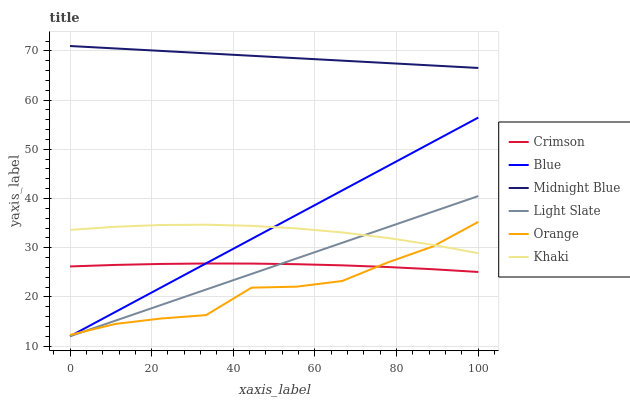Does Orange have the minimum area under the curve?
Answer yes or no. Yes. Does Midnight Blue have the maximum area under the curve?
Answer yes or no. Yes. Does Khaki have the minimum area under the curve?
Answer yes or no. No. Does Khaki have the maximum area under the curve?
Answer yes or no. No. Is Light Slate the smoothest?
Answer yes or no. Yes. Is Orange the roughest?
Answer yes or no. Yes. Is Khaki the smoothest?
Answer yes or no. No. Is Khaki the roughest?
Answer yes or no. No. Does Blue have the lowest value?
Answer yes or no. Yes. Does Khaki have the lowest value?
Answer yes or no. No. Does Midnight Blue have the highest value?
Answer yes or no. Yes. Does Khaki have the highest value?
Answer yes or no. No. Is Khaki less than Midnight Blue?
Answer yes or no. Yes. Is Khaki greater than Crimson?
Answer yes or no. Yes. Does Light Slate intersect Blue?
Answer yes or no. Yes. Is Light Slate less than Blue?
Answer yes or no. No. Is Light Slate greater than Blue?
Answer yes or no. No. Does Khaki intersect Midnight Blue?
Answer yes or no. No. 